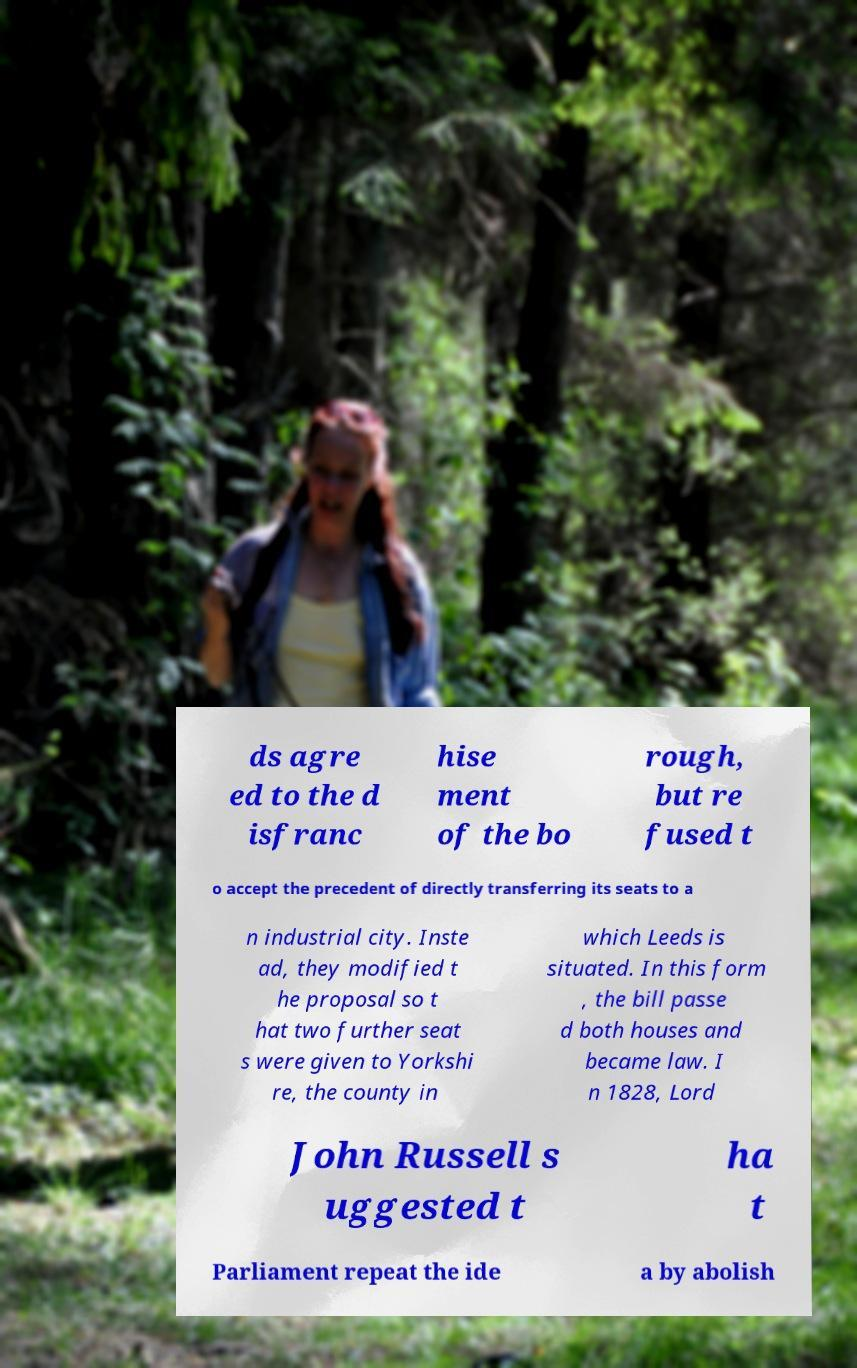Can you accurately transcribe the text from the provided image for me? ds agre ed to the d isfranc hise ment of the bo rough, but re fused t o accept the precedent of directly transferring its seats to a n industrial city. Inste ad, they modified t he proposal so t hat two further seat s were given to Yorkshi re, the county in which Leeds is situated. In this form , the bill passe d both houses and became law. I n 1828, Lord John Russell s uggested t ha t Parliament repeat the ide a by abolish 